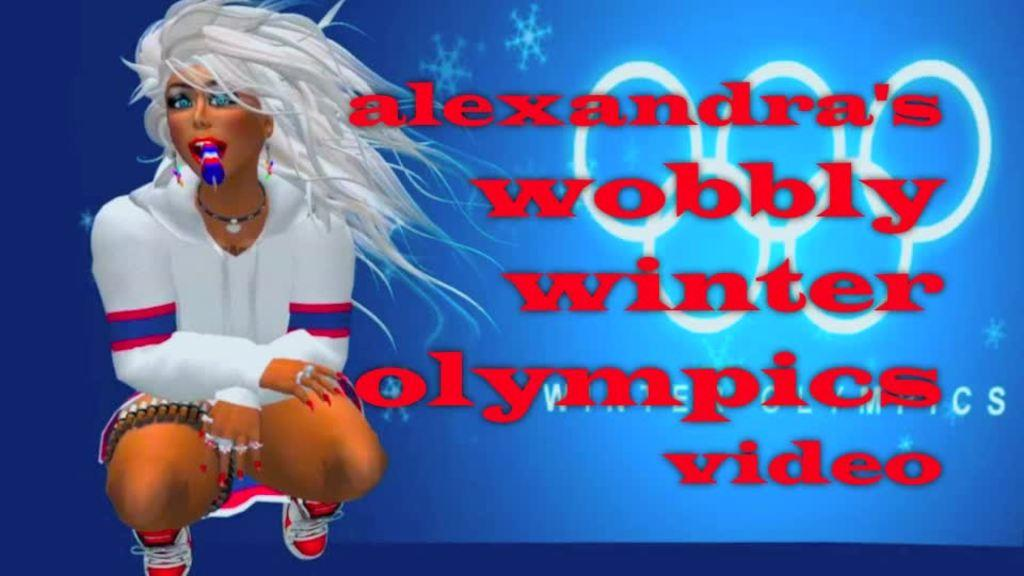What type of image is being described? The image is animated. Where is the person located in the image? The person is on the left side of the image. What is the person doing with the object in their mouth? The person is holding an object in their mouth. What position is the person in? The person is squatting. What can be seen on the right side of the image? There is text on the right side of the image. What type of cake is being served in the church in the image? There is no church or cake present in the image; it features an animated person holding an object in their mouth while squatting. 